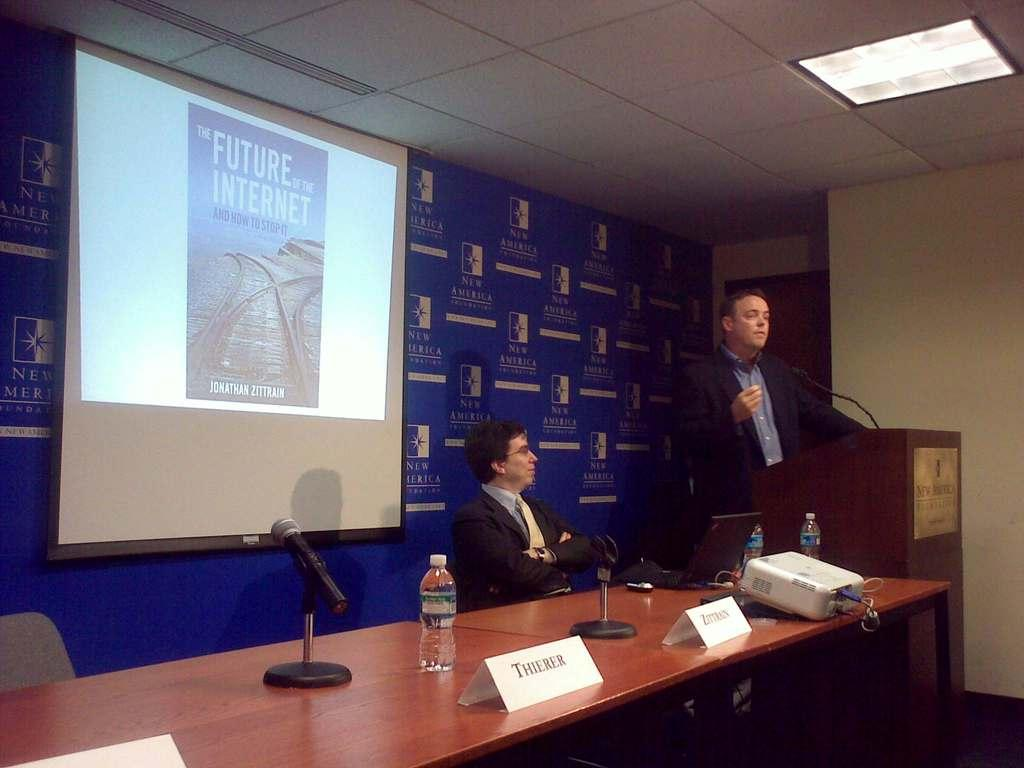<image>
Write a terse but informative summary of the picture. Two persons talking in a presentation of The Future of the Internet and How to Stop It by Jonathan Zittrain 